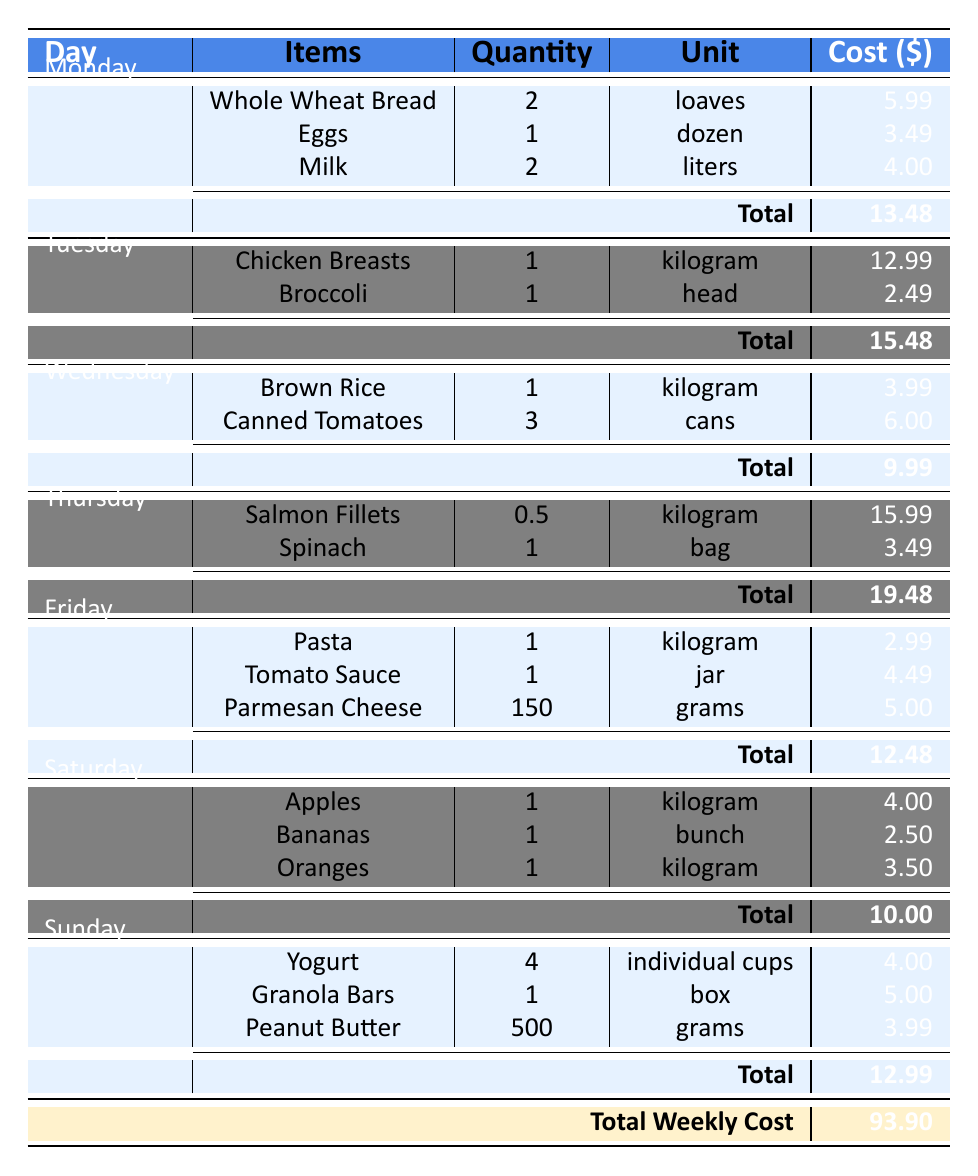What was the total cost for groceries on Tuesday? From the table, the total cost for groceries on Tuesday is explicitly listed as 15.48.
Answer: 15.48 Which day had the highest single-item expense? By examining each day, Thursday had the highest single item, Salmon Fillets, costing 15.99.
Answer: Thursday How much did the family spend on fruits over the week? The family's fruit purchases are listed under Saturday (Apples, Bananas, Oranges), totaling 10.00 for that day, and there are no other fruit purchases. Thus the total spent on fruits is 10.00.
Answer: 10.00 What is the average cost of groceries for the week? The total weekly cost is 93.90, divided by 7 days gives an average of 93.90 / 7 = 13.41.
Answer: 13.41 Did the family buy more dairy products or meat products? The dairy products are Milk (4.00) and Yogurt (4.00), totaling 8.00, while meat products include Chicken Breasts (12.99) and Salmon Fillets (15.99), totaling 28.98. Thus, the family bought more meat products.
Answer: Yes What was the total cost for groceries from Monday to Wednesday? The costs for these days are: Monday 13.48, Tuesday 15.48, and Wednesday 9.99. Adding these together gives 13.48 + 15.48 + 9.99 = 38.95.
Answer: 38.95 On which day did the family spend the least on groceries? By looking at the totals for each day, Wednesday had the least expenditure at 9.99.
Answer: Wednesday What is the difference in total cost between Thursday and Friday? The total cost on Thursday is 19.48, and Friday is 12.48. Therefore, the difference is 19.48 - 12.48 = 7.00.
Answer: 7.00 Was the total weekly grocery cost above 90 dollars? The total weekly grocery cost is 93.90, which is indeed above 90.
Answer: Yes 